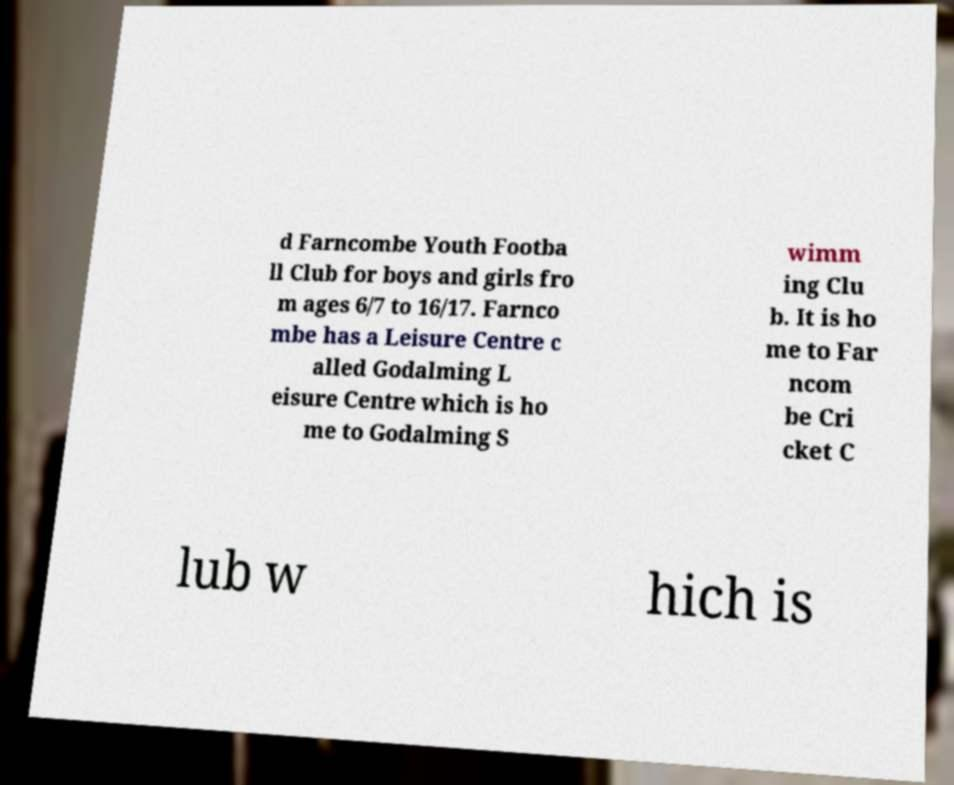Can you read and provide the text displayed in the image?This photo seems to have some interesting text. Can you extract and type it out for me? d Farncombe Youth Footba ll Club for boys and girls fro m ages 6/7 to 16/17. Farnco mbe has a Leisure Centre c alled Godalming L eisure Centre which is ho me to Godalming S wimm ing Clu b. It is ho me to Far ncom be Cri cket C lub w hich is 